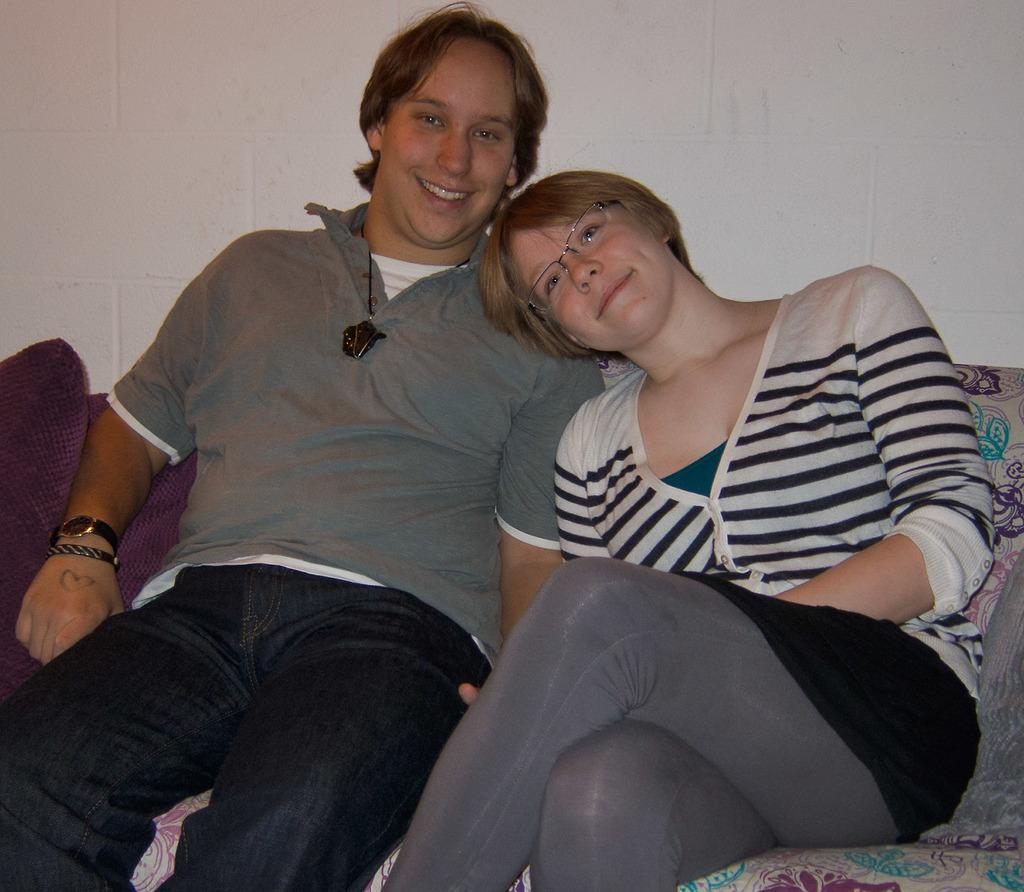How many people are sitting on the sofa in the image? There are two people sitting on the sofa in the image. What can be seen beside the people on the sofa? There are pillows beside the people on the sofa. What is located behind the people in the image? There is a wall behind the people in the image. What type of blade is being used by one of the people in the image? There is no blade present in the image; both people are sitting on the sofa with pillows beside them and a wall behind them. 